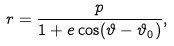Convert formula to latex. <formula><loc_0><loc_0><loc_500><loc_500>r = \frac { p } { 1 + e \cos ( \vartheta - \vartheta _ { 0 } ) } ,</formula> 